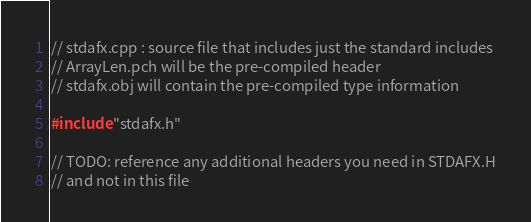<code> <loc_0><loc_0><loc_500><loc_500><_C++_>// stdafx.cpp : source file that includes just the standard includes
// ArrayLen.pch will be the pre-compiled header
// stdafx.obj will contain the pre-compiled type information

#include "stdafx.h"

// TODO: reference any additional headers you need in STDAFX.H
// and not in this file
</code> 